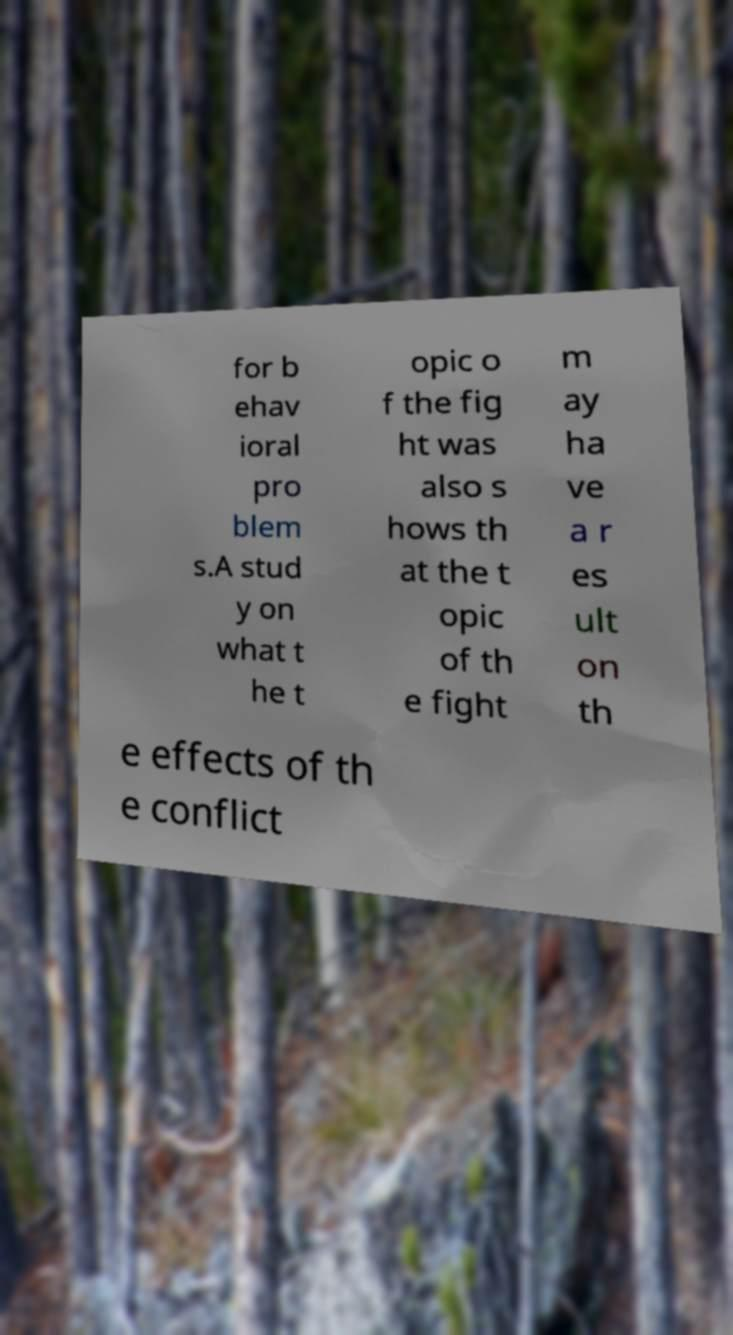Can you read and provide the text displayed in the image?This photo seems to have some interesting text. Can you extract and type it out for me? for b ehav ioral pro blem s.A stud y on what t he t opic o f the fig ht was also s hows th at the t opic of th e fight m ay ha ve a r es ult on th e effects of th e conflict 